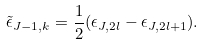Convert formula to latex. <formula><loc_0><loc_0><loc_500><loc_500>\tilde { \epsilon } _ { J - 1 , k } = \frac { 1 } { 2 } ( \epsilon _ { J , 2 l } - \epsilon _ { J , 2 l + 1 } ) .</formula> 